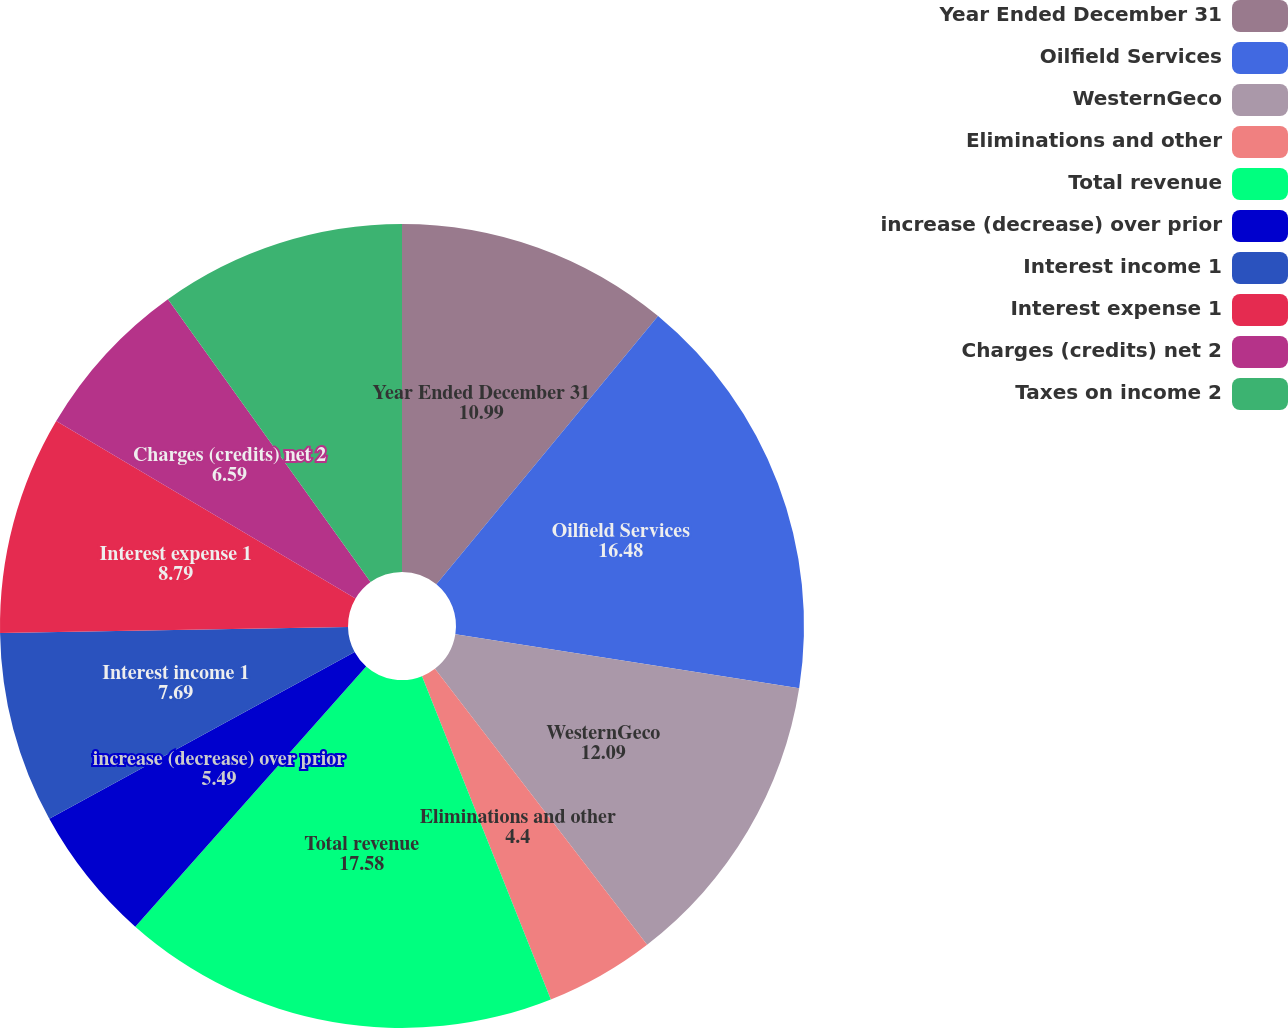Convert chart to OTSL. <chart><loc_0><loc_0><loc_500><loc_500><pie_chart><fcel>Year Ended December 31<fcel>Oilfield Services<fcel>WesternGeco<fcel>Eliminations and other<fcel>Total revenue<fcel>increase (decrease) over prior<fcel>Interest income 1<fcel>Interest expense 1<fcel>Charges (credits) net 2<fcel>Taxes on income 2<nl><fcel>10.99%<fcel>16.48%<fcel>12.09%<fcel>4.4%<fcel>17.58%<fcel>5.49%<fcel>7.69%<fcel>8.79%<fcel>6.59%<fcel>9.89%<nl></chart> 